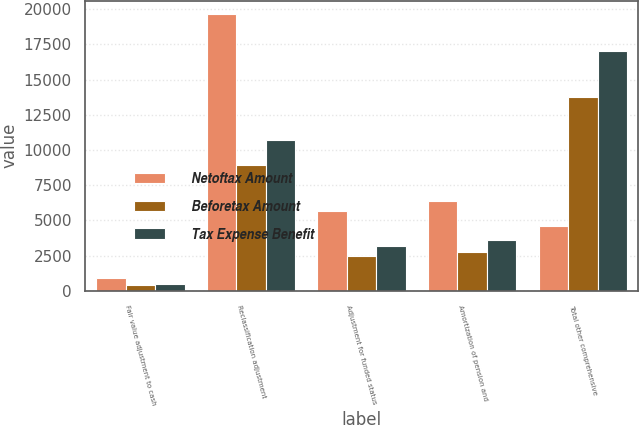Convert chart to OTSL. <chart><loc_0><loc_0><loc_500><loc_500><stacked_bar_chart><ecel><fcel>Fair value adjustment to cash<fcel>Reclassification adjustment<fcel>Adjustment for funded status<fcel>Amortization of pension and<fcel>Total other comprehensive<nl><fcel>Netoftax Amount<fcel>882<fcel>19619<fcel>5683<fcel>6371<fcel>4636.5<nl><fcel>Beforetax Amount<fcel>401<fcel>8910<fcel>2482<fcel>2781<fcel>13772<nl><fcel>Tax Expense Benefit<fcel>481<fcel>10709<fcel>3201<fcel>3590<fcel>17019<nl></chart> 